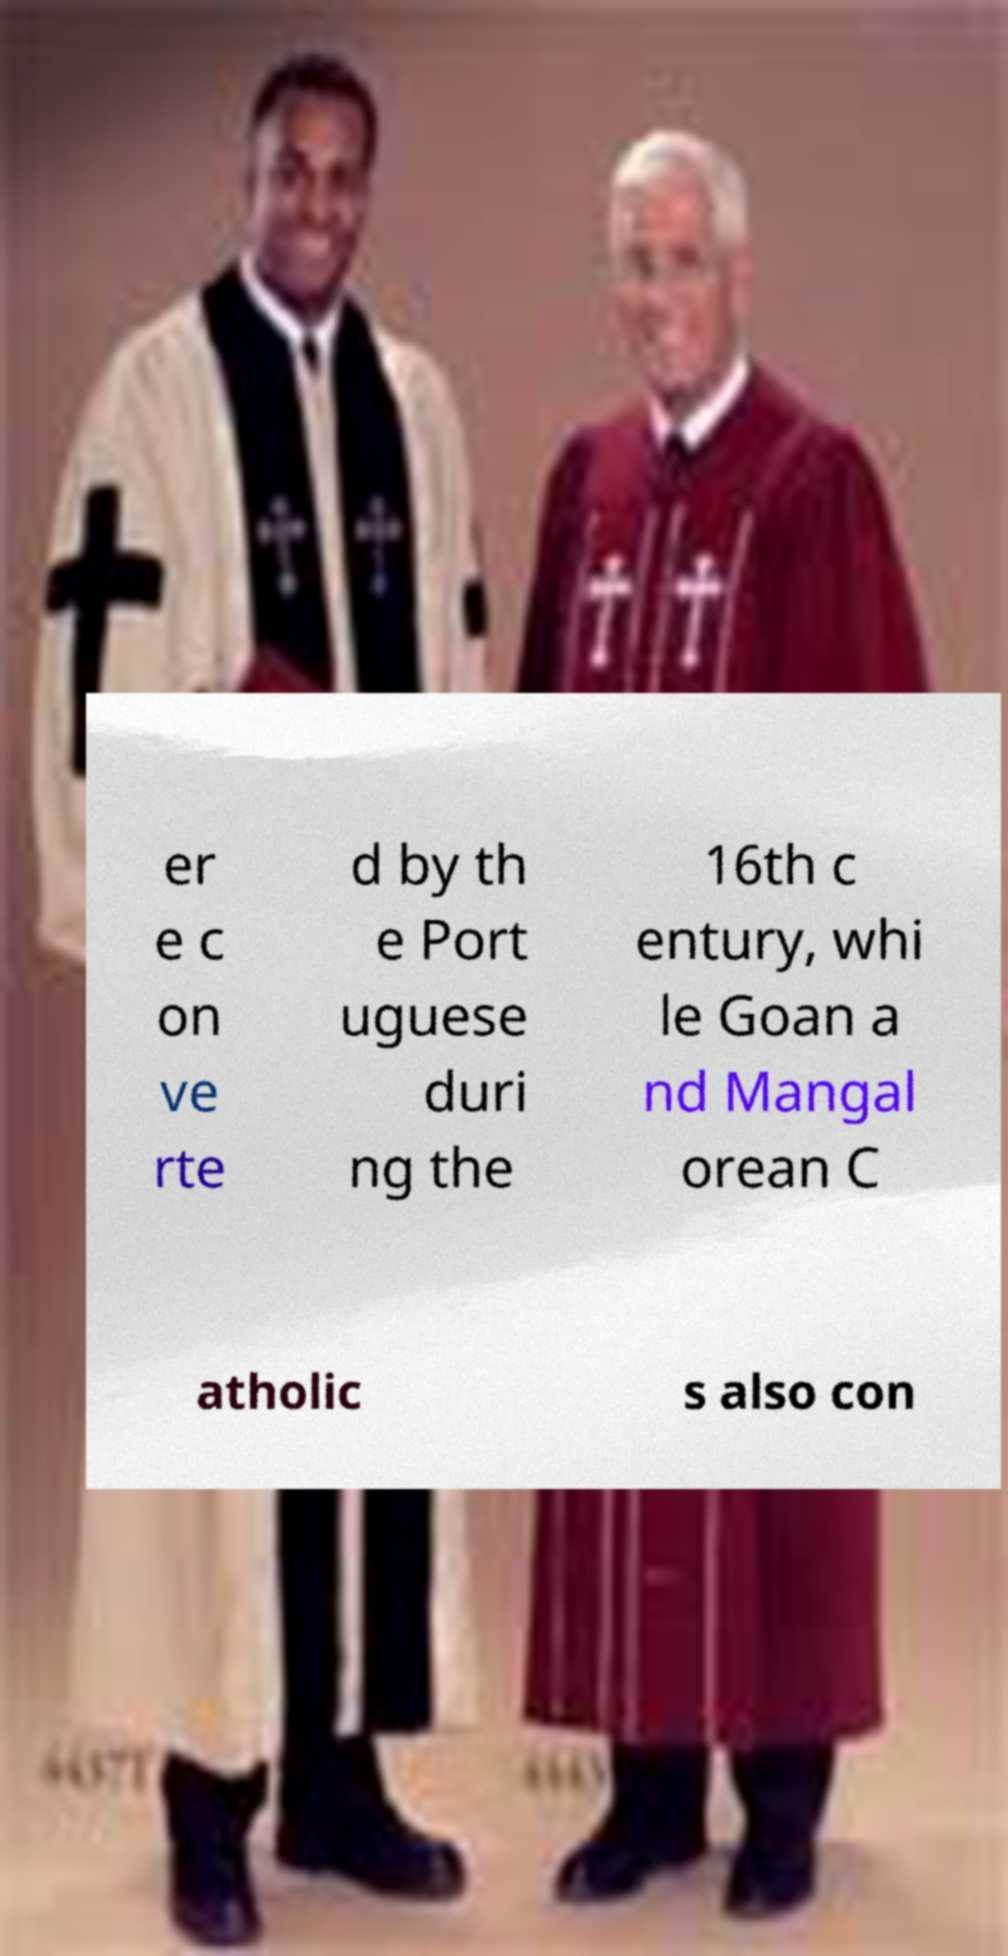Can you read and provide the text displayed in the image?This photo seems to have some interesting text. Can you extract and type it out for me? er e c on ve rte d by th e Port uguese duri ng the 16th c entury, whi le Goan a nd Mangal orean C atholic s also con 